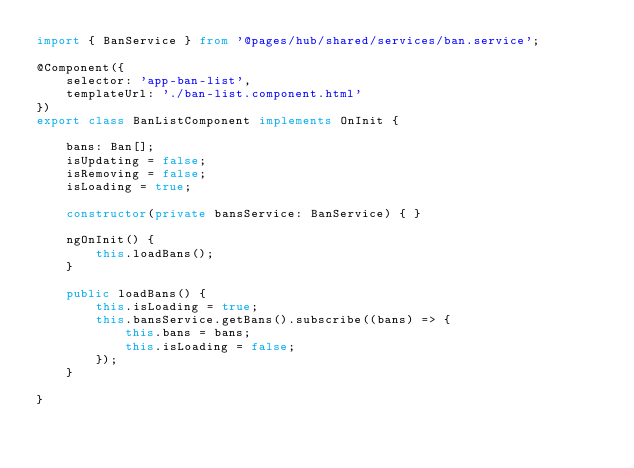<code> <loc_0><loc_0><loc_500><loc_500><_TypeScript_>import { BanService } from '@pages/hub/shared/services/ban.service';

@Component({
    selector: 'app-ban-list',
    templateUrl: './ban-list.component.html'
})
export class BanListComponent implements OnInit {

    bans: Ban[];
    isUpdating = false;
    isRemoving = false;
    isLoading = true;

    constructor(private bansService: BanService) { }

    ngOnInit() {
        this.loadBans();
    }

    public loadBans() {        
        this.isLoading = true;
        this.bansService.getBans().subscribe((bans) => {
            this.bans = bans;
            this.isLoading = false;
        });
    }

}
</code> 